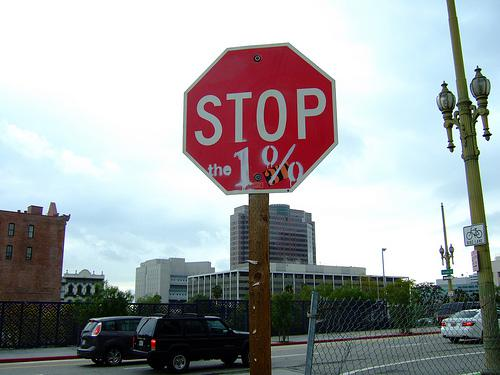Question: what color is the stop sign?
Choices:
A. Red.
B. Orange.
C. White.
D. Grey.
Answer with the letter. Answer: A Question: where was the picture taken?
Choices:
A. In the house.
B. On the street.
C. On the plane.
D. In the restaurant.
Answer with the letter. Answer: B Question: what is the stop sign pole made of?
Choices:
A. Metal.
B. Titanium.
C. Brick.
D. Wood.
Answer with the letter. Answer: D Question: how many stop signs are there?
Choices:
A. Two.
B. Zero.
C. Three.
D. One.
Answer with the letter. Answer: D 